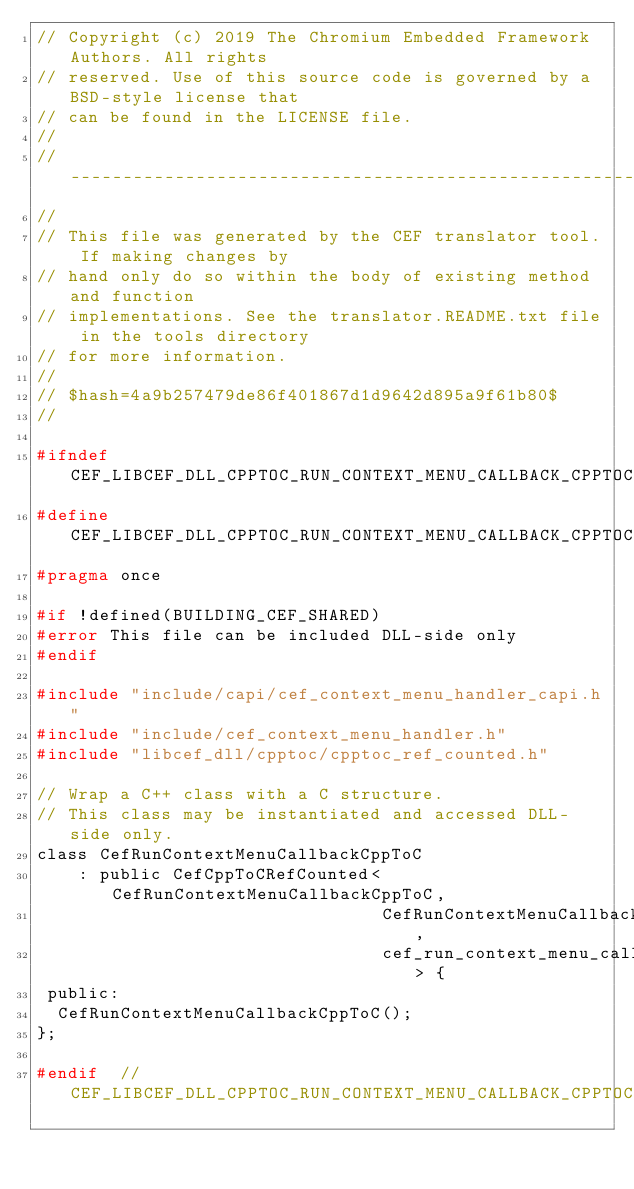Convert code to text. <code><loc_0><loc_0><loc_500><loc_500><_C_>// Copyright (c) 2019 The Chromium Embedded Framework Authors. All rights
// reserved. Use of this source code is governed by a BSD-style license that
// can be found in the LICENSE file.
//
// ---------------------------------------------------------------------------
//
// This file was generated by the CEF translator tool. If making changes by
// hand only do so within the body of existing method and function
// implementations. See the translator.README.txt file in the tools directory
// for more information.
//
// $hash=4a9b257479de86f401867d1d9642d895a9f61b80$
//

#ifndef CEF_LIBCEF_DLL_CPPTOC_RUN_CONTEXT_MENU_CALLBACK_CPPTOC_H_
#define CEF_LIBCEF_DLL_CPPTOC_RUN_CONTEXT_MENU_CALLBACK_CPPTOC_H_
#pragma once

#if !defined(BUILDING_CEF_SHARED)
#error This file can be included DLL-side only
#endif

#include "include/capi/cef_context_menu_handler_capi.h"
#include "include/cef_context_menu_handler.h"
#include "libcef_dll/cpptoc/cpptoc_ref_counted.h"

// Wrap a C++ class with a C structure.
// This class may be instantiated and accessed DLL-side only.
class CefRunContextMenuCallbackCppToC
    : public CefCppToCRefCounted<CefRunContextMenuCallbackCppToC,
                                 CefRunContextMenuCallback,
                                 cef_run_context_menu_callback_t> {
 public:
  CefRunContextMenuCallbackCppToC();
};

#endif  // CEF_LIBCEF_DLL_CPPTOC_RUN_CONTEXT_MENU_CALLBACK_CPPTOC_H_
</code> 